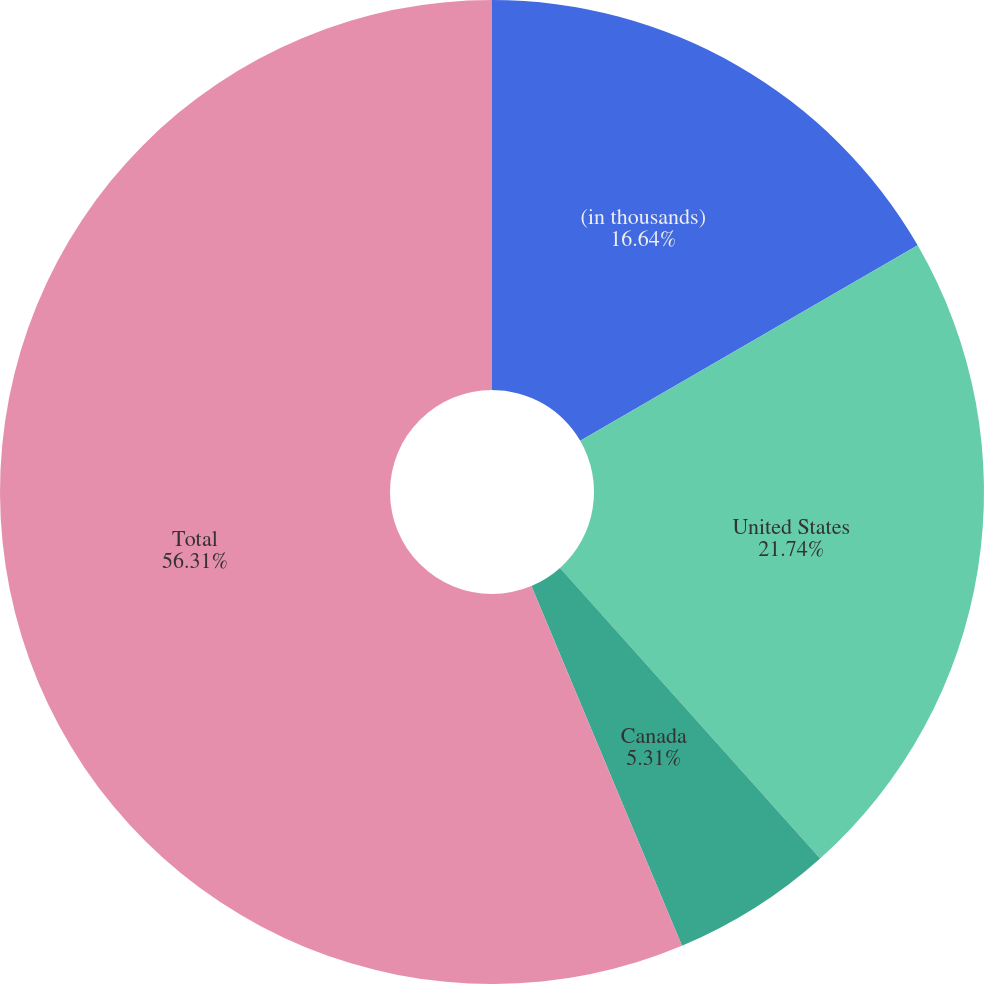Convert chart to OTSL. <chart><loc_0><loc_0><loc_500><loc_500><pie_chart><fcel>(in thousands)<fcel>United States<fcel>Canada<fcel>Total<nl><fcel>16.64%<fcel>21.74%<fcel>5.31%<fcel>56.31%<nl></chart> 